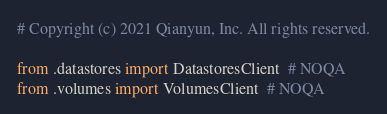<code> <loc_0><loc_0><loc_500><loc_500><_Python_># Copyright (c) 2021 Qianyun, Inc. All rights reserved.

from .datastores import DatastoresClient  # NOQA
from .volumes import VolumesClient  # NOQA
</code> 